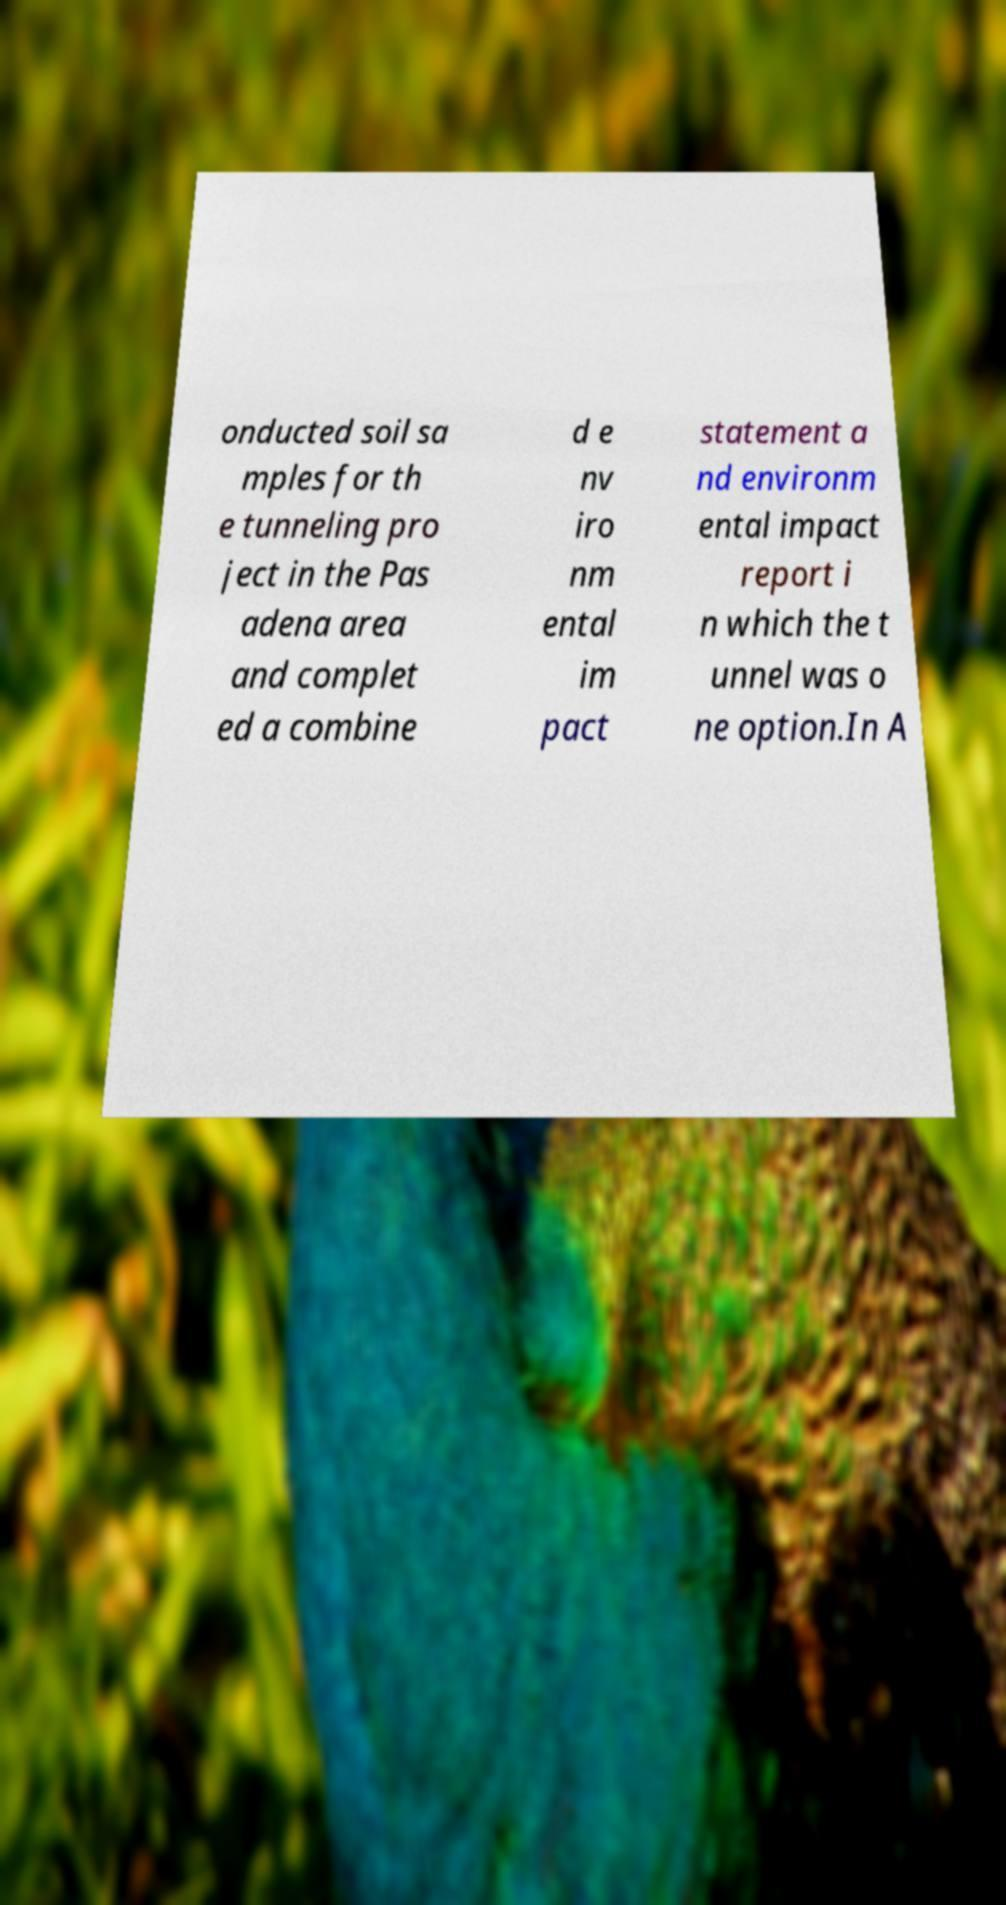I need the written content from this picture converted into text. Can you do that? onducted soil sa mples for th e tunneling pro ject in the Pas adena area and complet ed a combine d e nv iro nm ental im pact statement a nd environm ental impact report i n which the t unnel was o ne option.In A 